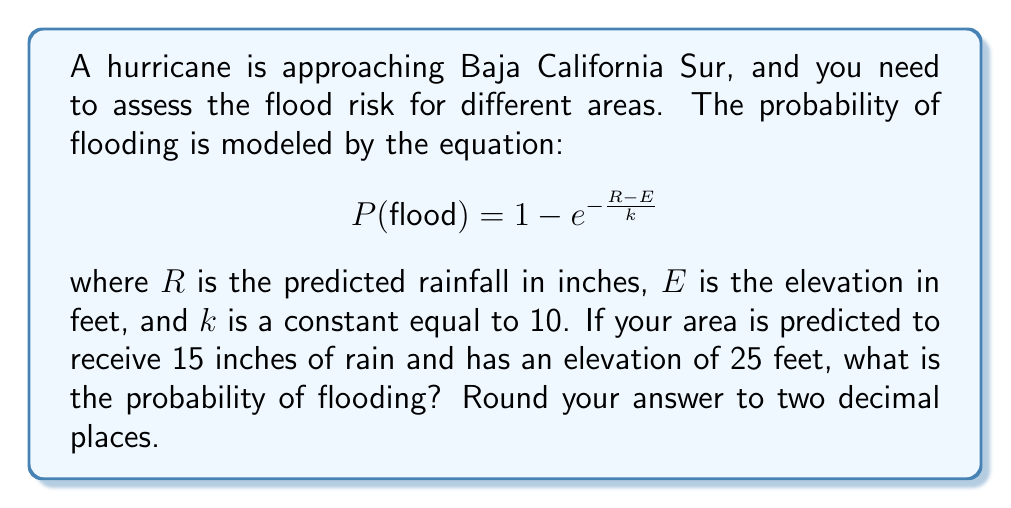Solve this math problem. To solve this problem, we'll follow these steps:

1. Identify the given values:
   $R = 15$ inches (predicted rainfall)
   $E = 25$ feet (elevation)
   $k = 10$ (constant)

2. Substitute these values into the equation:
   $$P(flood) = 1 - e^{-\frac{R-E}{k}}$$
   $$P(flood) = 1 - e^{-\frac{15-25}{10}}$$

3. Simplify the fraction inside the exponent:
   $$P(flood) = 1 - e^{-\frac{-10}{10}}$$
   $$P(flood) = 1 - e^{1}$$

4. Calculate $e^1$:
   $e^1 \approx 2.71828$

5. Subtract from 1:
   $$P(flood) = 1 - 2.71828 \approx -1.71828$$

6. Since probability cannot be negative, we set it to 0:
   $$P(flood) = 0$$

7. Round to two decimal places:
   $$P(flood) = 0.00$$

The probability of flooding is 0.00 or 0%, likely due to the area's elevation being higher than the predicted rainfall.
Answer: 0.00 